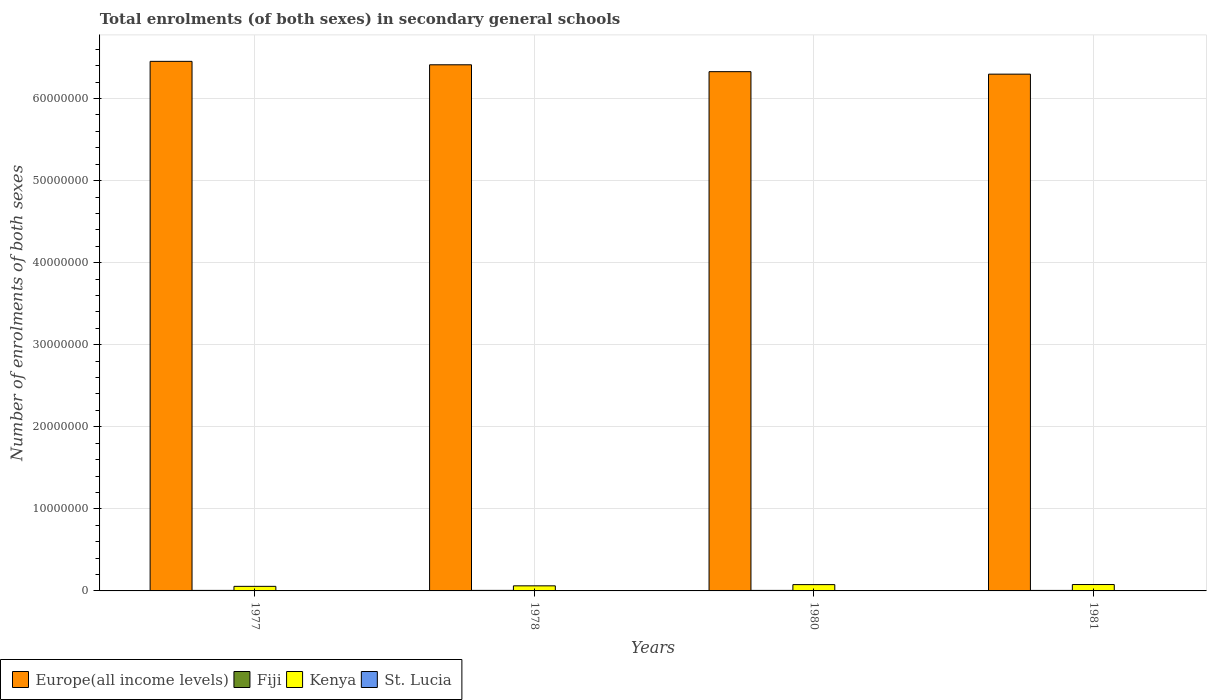How many groups of bars are there?
Keep it short and to the point. 4. In how many cases, is the number of bars for a given year not equal to the number of legend labels?
Keep it short and to the point. 0. What is the number of enrolments in secondary schools in Europe(all income levels) in 1981?
Keep it short and to the point. 6.30e+07. Across all years, what is the maximum number of enrolments in secondary schools in Europe(all income levels)?
Offer a very short reply. 6.45e+07. Across all years, what is the minimum number of enrolments in secondary schools in Fiji?
Give a very brief answer. 6.25e+04. In which year was the number of enrolments in secondary schools in Fiji maximum?
Your answer should be very brief. 1978. What is the total number of enrolments in secondary schools in Kenya in the graph?
Make the answer very short. 2.72e+06. What is the difference between the number of enrolments in secondary schools in Kenya in 1978 and that in 1981?
Keep it short and to the point. -1.58e+05. What is the difference between the number of enrolments in secondary schools in Kenya in 1977 and the number of enrolments in secondary schools in Fiji in 1978?
Give a very brief answer. 4.93e+05. What is the average number of enrolments in secondary schools in Kenya per year?
Offer a terse response. 6.81e+05. In the year 1981, what is the difference between the number of enrolments in secondary schools in St. Lucia and number of enrolments in secondary schools in Europe(all income levels)?
Offer a very short reply. -6.30e+07. In how many years, is the number of enrolments in secondary schools in Fiji greater than 12000000?
Offer a very short reply. 0. What is the ratio of the number of enrolments in secondary schools in Europe(all income levels) in 1978 to that in 1981?
Your response must be concise. 1.02. Is the number of enrolments in secondary schools in St. Lucia in 1978 less than that in 1981?
Your answer should be very brief. No. Is the difference between the number of enrolments in secondary schools in St. Lucia in 1978 and 1981 greater than the difference between the number of enrolments in secondary schools in Europe(all income levels) in 1978 and 1981?
Offer a terse response. No. What is the difference between the highest and the second highest number of enrolments in secondary schools in Europe(all income levels)?
Your response must be concise. 4.19e+05. What is the difference between the highest and the lowest number of enrolments in secondary schools in St. Lucia?
Offer a terse response. 688. Is it the case that in every year, the sum of the number of enrolments in secondary schools in Fiji and number of enrolments in secondary schools in Kenya is greater than the sum of number of enrolments in secondary schools in Europe(all income levels) and number of enrolments in secondary schools in St. Lucia?
Keep it short and to the point. No. What does the 4th bar from the left in 1977 represents?
Keep it short and to the point. St. Lucia. What does the 2nd bar from the right in 1977 represents?
Provide a succinct answer. Kenya. Is it the case that in every year, the sum of the number of enrolments in secondary schools in Kenya and number of enrolments in secondary schools in Europe(all income levels) is greater than the number of enrolments in secondary schools in Fiji?
Your answer should be very brief. Yes. How many bars are there?
Offer a very short reply. 16. Are all the bars in the graph horizontal?
Keep it short and to the point. No. How many years are there in the graph?
Ensure brevity in your answer.  4. Does the graph contain any zero values?
Keep it short and to the point. No. What is the title of the graph?
Keep it short and to the point. Total enrolments (of both sexes) in secondary general schools. Does "Brazil" appear as one of the legend labels in the graph?
Your answer should be very brief. No. What is the label or title of the Y-axis?
Offer a terse response. Number of enrolments of both sexes. What is the Number of enrolments of both sexes in Europe(all income levels) in 1977?
Your answer should be very brief. 6.45e+07. What is the Number of enrolments of both sexes in Fiji in 1977?
Your answer should be compact. 6.34e+04. What is the Number of enrolments of both sexes of Kenya in 1977?
Your answer should be compact. 5.57e+05. What is the Number of enrolments of both sexes of St. Lucia in 1977?
Keep it short and to the point. 4191. What is the Number of enrolments of both sexes of Europe(all income levels) in 1978?
Your answer should be very brief. 6.41e+07. What is the Number of enrolments of both sexes of Fiji in 1978?
Give a very brief answer. 6.48e+04. What is the Number of enrolments of both sexes of Kenya in 1978?
Offer a terse response. 6.20e+05. What is the Number of enrolments of both sexes in St. Lucia in 1978?
Your answer should be very brief. 4417. What is the Number of enrolments of both sexes of Europe(all income levels) in 1980?
Your answer should be compact. 6.33e+07. What is the Number of enrolments of both sexes of Fiji in 1980?
Offer a very short reply. 6.41e+04. What is the Number of enrolments of both sexes in Kenya in 1980?
Keep it short and to the point. 7.67e+05. What is the Number of enrolments of both sexes in St. Lucia in 1980?
Keep it short and to the point. 4879. What is the Number of enrolments of both sexes of Europe(all income levels) in 1981?
Provide a succinct answer. 6.30e+07. What is the Number of enrolments of both sexes of Fiji in 1981?
Keep it short and to the point. 6.25e+04. What is the Number of enrolments of both sexes of Kenya in 1981?
Ensure brevity in your answer.  7.78e+05. What is the Number of enrolments of both sexes in St. Lucia in 1981?
Offer a terse response. 4306. Across all years, what is the maximum Number of enrolments of both sexes in Europe(all income levels)?
Your answer should be very brief. 6.45e+07. Across all years, what is the maximum Number of enrolments of both sexes of Fiji?
Provide a short and direct response. 6.48e+04. Across all years, what is the maximum Number of enrolments of both sexes in Kenya?
Your answer should be very brief. 7.78e+05. Across all years, what is the maximum Number of enrolments of both sexes in St. Lucia?
Your answer should be very brief. 4879. Across all years, what is the minimum Number of enrolments of both sexes in Europe(all income levels)?
Provide a short and direct response. 6.30e+07. Across all years, what is the minimum Number of enrolments of both sexes in Fiji?
Provide a succinct answer. 6.25e+04. Across all years, what is the minimum Number of enrolments of both sexes of Kenya?
Provide a succinct answer. 5.57e+05. Across all years, what is the minimum Number of enrolments of both sexes of St. Lucia?
Your answer should be very brief. 4191. What is the total Number of enrolments of both sexes of Europe(all income levels) in the graph?
Give a very brief answer. 2.55e+08. What is the total Number of enrolments of both sexes of Fiji in the graph?
Give a very brief answer. 2.55e+05. What is the total Number of enrolments of both sexes of Kenya in the graph?
Offer a terse response. 2.72e+06. What is the total Number of enrolments of both sexes of St. Lucia in the graph?
Provide a succinct answer. 1.78e+04. What is the difference between the Number of enrolments of both sexes in Europe(all income levels) in 1977 and that in 1978?
Provide a short and direct response. 4.19e+05. What is the difference between the Number of enrolments of both sexes of Fiji in 1977 and that in 1978?
Provide a succinct answer. -1336. What is the difference between the Number of enrolments of both sexes of Kenya in 1977 and that in 1978?
Give a very brief answer. -6.27e+04. What is the difference between the Number of enrolments of both sexes in St. Lucia in 1977 and that in 1978?
Your answer should be compact. -226. What is the difference between the Number of enrolments of both sexes in Europe(all income levels) in 1977 and that in 1980?
Provide a succinct answer. 1.26e+06. What is the difference between the Number of enrolments of both sexes of Fiji in 1977 and that in 1980?
Ensure brevity in your answer.  -692. What is the difference between the Number of enrolments of both sexes of Kenya in 1977 and that in 1980?
Your answer should be very brief. -2.10e+05. What is the difference between the Number of enrolments of both sexes in St. Lucia in 1977 and that in 1980?
Offer a very short reply. -688. What is the difference between the Number of enrolments of both sexes of Europe(all income levels) in 1977 and that in 1981?
Offer a very short reply. 1.56e+06. What is the difference between the Number of enrolments of both sexes in Fiji in 1977 and that in 1981?
Ensure brevity in your answer.  958. What is the difference between the Number of enrolments of both sexes of Kenya in 1977 and that in 1981?
Provide a succinct answer. -2.21e+05. What is the difference between the Number of enrolments of both sexes in St. Lucia in 1977 and that in 1981?
Ensure brevity in your answer.  -115. What is the difference between the Number of enrolments of both sexes of Europe(all income levels) in 1978 and that in 1980?
Give a very brief answer. 8.38e+05. What is the difference between the Number of enrolments of both sexes of Fiji in 1978 and that in 1980?
Offer a terse response. 644. What is the difference between the Number of enrolments of both sexes of Kenya in 1978 and that in 1980?
Offer a very short reply. -1.47e+05. What is the difference between the Number of enrolments of both sexes in St. Lucia in 1978 and that in 1980?
Keep it short and to the point. -462. What is the difference between the Number of enrolments of both sexes in Europe(all income levels) in 1978 and that in 1981?
Your answer should be compact. 1.14e+06. What is the difference between the Number of enrolments of both sexes in Fiji in 1978 and that in 1981?
Keep it short and to the point. 2294. What is the difference between the Number of enrolments of both sexes of Kenya in 1978 and that in 1981?
Your response must be concise. -1.58e+05. What is the difference between the Number of enrolments of both sexes in St. Lucia in 1978 and that in 1981?
Your answer should be compact. 111. What is the difference between the Number of enrolments of both sexes in Europe(all income levels) in 1980 and that in 1981?
Provide a short and direct response. 3.02e+05. What is the difference between the Number of enrolments of both sexes of Fiji in 1980 and that in 1981?
Your answer should be compact. 1650. What is the difference between the Number of enrolments of both sexes of Kenya in 1980 and that in 1981?
Give a very brief answer. -1.10e+04. What is the difference between the Number of enrolments of both sexes in St. Lucia in 1980 and that in 1981?
Your answer should be compact. 573. What is the difference between the Number of enrolments of both sexes of Europe(all income levels) in 1977 and the Number of enrolments of both sexes of Fiji in 1978?
Give a very brief answer. 6.45e+07. What is the difference between the Number of enrolments of both sexes of Europe(all income levels) in 1977 and the Number of enrolments of both sexes of Kenya in 1978?
Ensure brevity in your answer.  6.39e+07. What is the difference between the Number of enrolments of both sexes in Europe(all income levels) in 1977 and the Number of enrolments of both sexes in St. Lucia in 1978?
Your response must be concise. 6.45e+07. What is the difference between the Number of enrolments of both sexes in Fiji in 1977 and the Number of enrolments of both sexes in Kenya in 1978?
Your response must be concise. -5.57e+05. What is the difference between the Number of enrolments of both sexes in Fiji in 1977 and the Number of enrolments of both sexes in St. Lucia in 1978?
Make the answer very short. 5.90e+04. What is the difference between the Number of enrolments of both sexes of Kenya in 1977 and the Number of enrolments of both sexes of St. Lucia in 1978?
Ensure brevity in your answer.  5.53e+05. What is the difference between the Number of enrolments of both sexes in Europe(all income levels) in 1977 and the Number of enrolments of both sexes in Fiji in 1980?
Your response must be concise. 6.45e+07. What is the difference between the Number of enrolments of both sexes of Europe(all income levels) in 1977 and the Number of enrolments of both sexes of Kenya in 1980?
Ensure brevity in your answer.  6.38e+07. What is the difference between the Number of enrolments of both sexes in Europe(all income levels) in 1977 and the Number of enrolments of both sexes in St. Lucia in 1980?
Keep it short and to the point. 6.45e+07. What is the difference between the Number of enrolments of both sexes in Fiji in 1977 and the Number of enrolments of both sexes in Kenya in 1980?
Offer a terse response. -7.04e+05. What is the difference between the Number of enrolments of both sexes of Fiji in 1977 and the Number of enrolments of both sexes of St. Lucia in 1980?
Your response must be concise. 5.86e+04. What is the difference between the Number of enrolments of both sexes in Kenya in 1977 and the Number of enrolments of both sexes in St. Lucia in 1980?
Your answer should be very brief. 5.53e+05. What is the difference between the Number of enrolments of both sexes in Europe(all income levels) in 1977 and the Number of enrolments of both sexes in Fiji in 1981?
Provide a short and direct response. 6.45e+07. What is the difference between the Number of enrolments of both sexes in Europe(all income levels) in 1977 and the Number of enrolments of both sexes in Kenya in 1981?
Give a very brief answer. 6.38e+07. What is the difference between the Number of enrolments of both sexes of Europe(all income levels) in 1977 and the Number of enrolments of both sexes of St. Lucia in 1981?
Give a very brief answer. 6.45e+07. What is the difference between the Number of enrolments of both sexes in Fiji in 1977 and the Number of enrolments of both sexes in Kenya in 1981?
Ensure brevity in your answer.  -7.15e+05. What is the difference between the Number of enrolments of both sexes in Fiji in 1977 and the Number of enrolments of both sexes in St. Lucia in 1981?
Your answer should be compact. 5.91e+04. What is the difference between the Number of enrolments of both sexes of Kenya in 1977 and the Number of enrolments of both sexes of St. Lucia in 1981?
Ensure brevity in your answer.  5.53e+05. What is the difference between the Number of enrolments of both sexes of Europe(all income levels) in 1978 and the Number of enrolments of both sexes of Fiji in 1980?
Make the answer very short. 6.41e+07. What is the difference between the Number of enrolments of both sexes in Europe(all income levels) in 1978 and the Number of enrolments of both sexes in Kenya in 1980?
Your answer should be very brief. 6.33e+07. What is the difference between the Number of enrolments of both sexes in Europe(all income levels) in 1978 and the Number of enrolments of both sexes in St. Lucia in 1980?
Your response must be concise. 6.41e+07. What is the difference between the Number of enrolments of both sexes of Fiji in 1978 and the Number of enrolments of both sexes of Kenya in 1980?
Your response must be concise. -7.03e+05. What is the difference between the Number of enrolments of both sexes in Fiji in 1978 and the Number of enrolments of both sexes in St. Lucia in 1980?
Provide a short and direct response. 5.99e+04. What is the difference between the Number of enrolments of both sexes in Kenya in 1978 and the Number of enrolments of both sexes in St. Lucia in 1980?
Offer a terse response. 6.15e+05. What is the difference between the Number of enrolments of both sexes in Europe(all income levels) in 1978 and the Number of enrolments of both sexes in Fiji in 1981?
Provide a succinct answer. 6.41e+07. What is the difference between the Number of enrolments of both sexes of Europe(all income levels) in 1978 and the Number of enrolments of both sexes of Kenya in 1981?
Give a very brief answer. 6.33e+07. What is the difference between the Number of enrolments of both sexes of Europe(all income levels) in 1978 and the Number of enrolments of both sexes of St. Lucia in 1981?
Your answer should be very brief. 6.41e+07. What is the difference between the Number of enrolments of both sexes of Fiji in 1978 and the Number of enrolments of both sexes of Kenya in 1981?
Your response must be concise. -7.14e+05. What is the difference between the Number of enrolments of both sexes of Fiji in 1978 and the Number of enrolments of both sexes of St. Lucia in 1981?
Provide a succinct answer. 6.05e+04. What is the difference between the Number of enrolments of both sexes of Kenya in 1978 and the Number of enrolments of both sexes of St. Lucia in 1981?
Give a very brief answer. 6.16e+05. What is the difference between the Number of enrolments of both sexes of Europe(all income levels) in 1980 and the Number of enrolments of both sexes of Fiji in 1981?
Your answer should be very brief. 6.32e+07. What is the difference between the Number of enrolments of both sexes of Europe(all income levels) in 1980 and the Number of enrolments of both sexes of Kenya in 1981?
Provide a short and direct response. 6.25e+07. What is the difference between the Number of enrolments of both sexes of Europe(all income levels) in 1980 and the Number of enrolments of both sexes of St. Lucia in 1981?
Provide a succinct answer. 6.33e+07. What is the difference between the Number of enrolments of both sexes of Fiji in 1980 and the Number of enrolments of both sexes of Kenya in 1981?
Offer a terse response. -7.14e+05. What is the difference between the Number of enrolments of both sexes of Fiji in 1980 and the Number of enrolments of both sexes of St. Lucia in 1981?
Keep it short and to the point. 5.98e+04. What is the difference between the Number of enrolments of both sexes of Kenya in 1980 and the Number of enrolments of both sexes of St. Lucia in 1981?
Keep it short and to the point. 7.63e+05. What is the average Number of enrolments of both sexes of Europe(all income levels) per year?
Provide a short and direct response. 6.37e+07. What is the average Number of enrolments of both sexes in Fiji per year?
Keep it short and to the point. 6.37e+04. What is the average Number of enrolments of both sexes of Kenya per year?
Give a very brief answer. 6.81e+05. What is the average Number of enrolments of both sexes of St. Lucia per year?
Your answer should be compact. 4448.25. In the year 1977, what is the difference between the Number of enrolments of both sexes in Europe(all income levels) and Number of enrolments of both sexes in Fiji?
Your answer should be very brief. 6.45e+07. In the year 1977, what is the difference between the Number of enrolments of both sexes of Europe(all income levels) and Number of enrolments of both sexes of Kenya?
Ensure brevity in your answer.  6.40e+07. In the year 1977, what is the difference between the Number of enrolments of both sexes in Europe(all income levels) and Number of enrolments of both sexes in St. Lucia?
Keep it short and to the point. 6.45e+07. In the year 1977, what is the difference between the Number of enrolments of both sexes in Fiji and Number of enrolments of both sexes in Kenya?
Your answer should be compact. -4.94e+05. In the year 1977, what is the difference between the Number of enrolments of both sexes in Fiji and Number of enrolments of both sexes in St. Lucia?
Keep it short and to the point. 5.93e+04. In the year 1977, what is the difference between the Number of enrolments of both sexes in Kenya and Number of enrolments of both sexes in St. Lucia?
Make the answer very short. 5.53e+05. In the year 1978, what is the difference between the Number of enrolments of both sexes in Europe(all income levels) and Number of enrolments of both sexes in Fiji?
Provide a short and direct response. 6.41e+07. In the year 1978, what is the difference between the Number of enrolments of both sexes of Europe(all income levels) and Number of enrolments of both sexes of Kenya?
Provide a succinct answer. 6.35e+07. In the year 1978, what is the difference between the Number of enrolments of both sexes of Europe(all income levels) and Number of enrolments of both sexes of St. Lucia?
Make the answer very short. 6.41e+07. In the year 1978, what is the difference between the Number of enrolments of both sexes in Fiji and Number of enrolments of both sexes in Kenya?
Make the answer very short. -5.55e+05. In the year 1978, what is the difference between the Number of enrolments of both sexes in Fiji and Number of enrolments of both sexes in St. Lucia?
Your answer should be compact. 6.04e+04. In the year 1978, what is the difference between the Number of enrolments of both sexes of Kenya and Number of enrolments of both sexes of St. Lucia?
Provide a short and direct response. 6.16e+05. In the year 1980, what is the difference between the Number of enrolments of both sexes in Europe(all income levels) and Number of enrolments of both sexes in Fiji?
Make the answer very short. 6.32e+07. In the year 1980, what is the difference between the Number of enrolments of both sexes of Europe(all income levels) and Number of enrolments of both sexes of Kenya?
Keep it short and to the point. 6.25e+07. In the year 1980, what is the difference between the Number of enrolments of both sexes of Europe(all income levels) and Number of enrolments of both sexes of St. Lucia?
Ensure brevity in your answer.  6.33e+07. In the year 1980, what is the difference between the Number of enrolments of both sexes of Fiji and Number of enrolments of both sexes of Kenya?
Your answer should be very brief. -7.03e+05. In the year 1980, what is the difference between the Number of enrolments of both sexes of Fiji and Number of enrolments of both sexes of St. Lucia?
Your response must be concise. 5.93e+04. In the year 1980, what is the difference between the Number of enrolments of both sexes in Kenya and Number of enrolments of both sexes in St. Lucia?
Keep it short and to the point. 7.62e+05. In the year 1981, what is the difference between the Number of enrolments of both sexes in Europe(all income levels) and Number of enrolments of both sexes in Fiji?
Provide a succinct answer. 6.29e+07. In the year 1981, what is the difference between the Number of enrolments of both sexes in Europe(all income levels) and Number of enrolments of both sexes in Kenya?
Provide a short and direct response. 6.22e+07. In the year 1981, what is the difference between the Number of enrolments of both sexes of Europe(all income levels) and Number of enrolments of both sexes of St. Lucia?
Make the answer very short. 6.30e+07. In the year 1981, what is the difference between the Number of enrolments of both sexes in Fiji and Number of enrolments of both sexes in Kenya?
Make the answer very short. -7.16e+05. In the year 1981, what is the difference between the Number of enrolments of both sexes of Fiji and Number of enrolments of both sexes of St. Lucia?
Offer a terse response. 5.82e+04. In the year 1981, what is the difference between the Number of enrolments of both sexes of Kenya and Number of enrolments of both sexes of St. Lucia?
Your answer should be very brief. 7.74e+05. What is the ratio of the Number of enrolments of both sexes in Europe(all income levels) in 1977 to that in 1978?
Keep it short and to the point. 1.01. What is the ratio of the Number of enrolments of both sexes in Fiji in 1977 to that in 1978?
Give a very brief answer. 0.98. What is the ratio of the Number of enrolments of both sexes in Kenya in 1977 to that in 1978?
Ensure brevity in your answer.  0.9. What is the ratio of the Number of enrolments of both sexes of St. Lucia in 1977 to that in 1978?
Offer a very short reply. 0.95. What is the ratio of the Number of enrolments of both sexes of Europe(all income levels) in 1977 to that in 1980?
Your answer should be compact. 1.02. What is the ratio of the Number of enrolments of both sexes in Kenya in 1977 to that in 1980?
Make the answer very short. 0.73. What is the ratio of the Number of enrolments of both sexes of St. Lucia in 1977 to that in 1980?
Provide a succinct answer. 0.86. What is the ratio of the Number of enrolments of both sexes of Europe(all income levels) in 1977 to that in 1981?
Make the answer very short. 1.02. What is the ratio of the Number of enrolments of both sexes in Fiji in 1977 to that in 1981?
Provide a succinct answer. 1.02. What is the ratio of the Number of enrolments of both sexes of Kenya in 1977 to that in 1981?
Your answer should be very brief. 0.72. What is the ratio of the Number of enrolments of both sexes of St. Lucia in 1977 to that in 1981?
Keep it short and to the point. 0.97. What is the ratio of the Number of enrolments of both sexes of Europe(all income levels) in 1978 to that in 1980?
Your answer should be very brief. 1.01. What is the ratio of the Number of enrolments of both sexes in Kenya in 1978 to that in 1980?
Your response must be concise. 0.81. What is the ratio of the Number of enrolments of both sexes in St. Lucia in 1978 to that in 1980?
Your answer should be very brief. 0.91. What is the ratio of the Number of enrolments of both sexes in Europe(all income levels) in 1978 to that in 1981?
Offer a terse response. 1.02. What is the ratio of the Number of enrolments of both sexes in Fiji in 1978 to that in 1981?
Provide a succinct answer. 1.04. What is the ratio of the Number of enrolments of both sexes in Kenya in 1978 to that in 1981?
Give a very brief answer. 0.8. What is the ratio of the Number of enrolments of both sexes of St. Lucia in 1978 to that in 1981?
Your response must be concise. 1.03. What is the ratio of the Number of enrolments of both sexes of Fiji in 1980 to that in 1981?
Offer a terse response. 1.03. What is the ratio of the Number of enrolments of both sexes of Kenya in 1980 to that in 1981?
Ensure brevity in your answer.  0.99. What is the ratio of the Number of enrolments of both sexes in St. Lucia in 1980 to that in 1981?
Your answer should be compact. 1.13. What is the difference between the highest and the second highest Number of enrolments of both sexes in Europe(all income levels)?
Provide a succinct answer. 4.19e+05. What is the difference between the highest and the second highest Number of enrolments of both sexes of Fiji?
Provide a succinct answer. 644. What is the difference between the highest and the second highest Number of enrolments of both sexes of Kenya?
Keep it short and to the point. 1.10e+04. What is the difference between the highest and the second highest Number of enrolments of both sexes of St. Lucia?
Your answer should be very brief. 462. What is the difference between the highest and the lowest Number of enrolments of both sexes of Europe(all income levels)?
Your answer should be very brief. 1.56e+06. What is the difference between the highest and the lowest Number of enrolments of both sexes of Fiji?
Offer a very short reply. 2294. What is the difference between the highest and the lowest Number of enrolments of both sexes in Kenya?
Your answer should be very brief. 2.21e+05. What is the difference between the highest and the lowest Number of enrolments of both sexes in St. Lucia?
Make the answer very short. 688. 